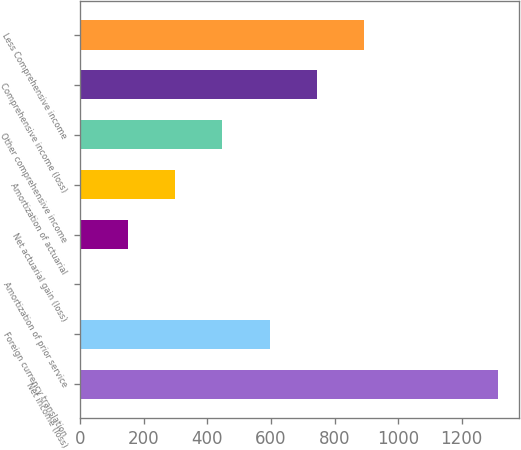Convert chart to OTSL. <chart><loc_0><loc_0><loc_500><loc_500><bar_chart><fcel>Net income (loss)<fcel>Foreign currency translation<fcel>Amortization of prior service<fcel>Net actuarial gain (loss)<fcel>Amortization of actuarial<fcel>Other comprehensive income<fcel>Comprehensive income (loss)<fcel>Less Comprehensive income<nl><fcel>1314<fcel>595.8<fcel>3<fcel>151.2<fcel>299.4<fcel>447.6<fcel>744<fcel>892.2<nl></chart> 